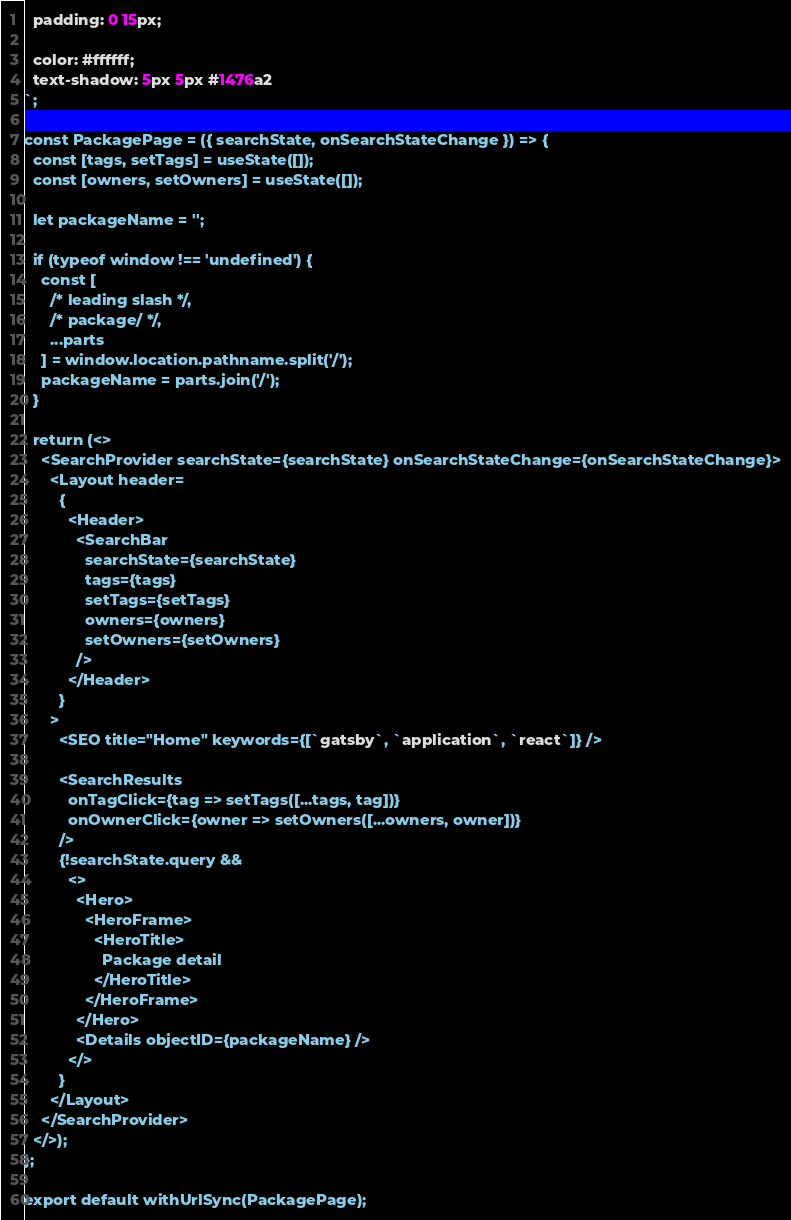<code> <loc_0><loc_0><loc_500><loc_500><_JavaScript_>  padding: 0 15px;

  color: #ffffff;
  text-shadow: 5px 5px #1476a2
`;

const PackagePage = ({ searchState, onSearchStateChange }) => {
  const [tags, setTags] = useState([]);
  const [owners, setOwners] = useState([]);

  let packageName = '';

  if (typeof window !== 'undefined') {
    const [
      /* leading slash */,
      /* package/ */,
      ...parts
    ] = window.location.pathname.split('/');
    packageName = parts.join('/');
  }

  return (<>
    <SearchProvider searchState={searchState} onSearchStateChange={onSearchStateChange}>
      <Layout header=
        {
          <Header>
            <SearchBar
              searchState={searchState}
              tags={tags}
              setTags={setTags}
              owners={owners}
              setOwners={setOwners}
            />
          </Header>
        }
      >
        <SEO title="Home" keywords={[`gatsby`, `application`, `react`]} />

        <SearchResults
          onTagClick={tag => setTags([...tags, tag])}
          onOwnerClick={owner => setOwners([...owners, owner])}
        />
        {!searchState.query &&
          <>
            <Hero>
              <HeroFrame>
                <HeroTitle>
                  Package detail
                </HeroTitle>
              </HeroFrame>
            </Hero>
            <Details objectID={packageName} />
          </>
        }
      </Layout>
    </SearchProvider>
  </>);
};

export default withUrlSync(PackagePage);
</code> 